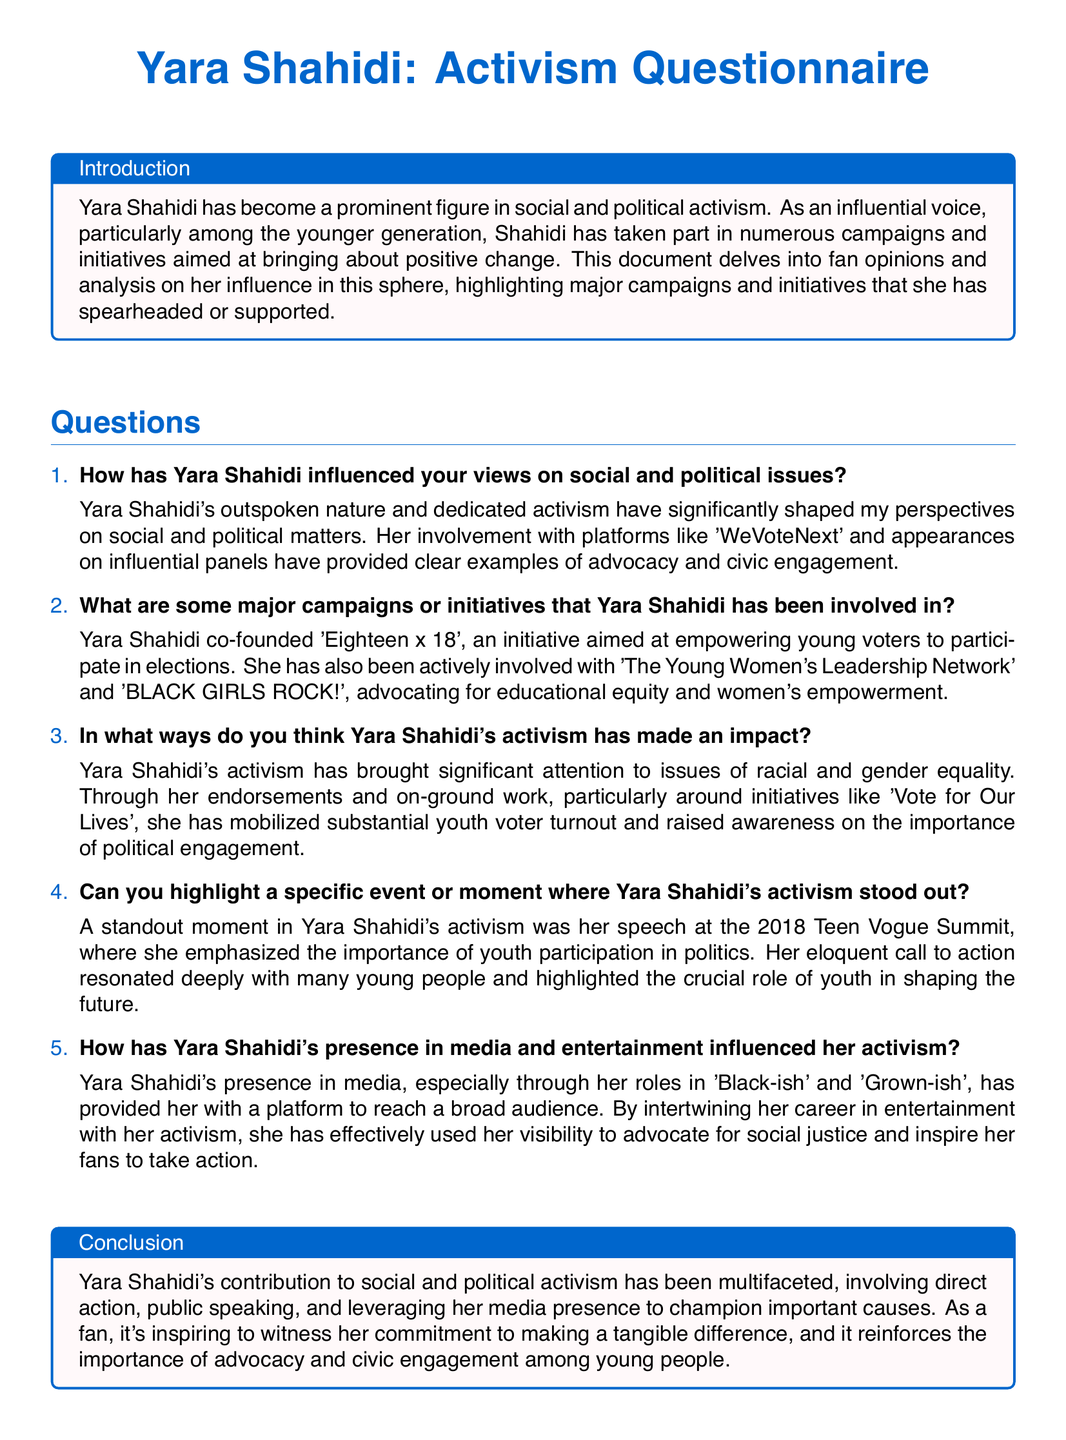What is Yara Shahidi's initiative aimed at empowering young voters? The document states that Yara Shahidi co-founded 'Eighteen x 18', which focuses on empowering young voters.
Answer: 'Eighteen x 18' What event highlighted Yara Shahidi's activism in 2018? The document mentions her speech at the 2018 Teen Vogue Summit as a significant moment for her activism.
Answer: 2018 Teen Vogue Summit What organization is Yara Shahidi involved with that advocates for educational equity? According to the document, she is actively involved with 'The Young Women's Leadership Network', which advocates for educational equity.
Answer: 'The Young Women's Leadership Network' How has Yara Shahidi's activism impacted youth voter turnout? The document describes her mobilization of youth voter turnout through initiatives like 'Vote for Our Lives'.
Answer: Mobilized youth voter turnout What role does Yara Shahidi have in media that aids her activism? The document states that she has roles in 'Black-ish' and 'Grown-ish', which help reach a broad audience for her activism.
Answer: 'Black-ish' and 'Grown-ish' What major themes does Yara Shahidi focus on in her activism? The document identifies racial and gender equality as significant themes in her activism.
Answer: Racial and gender equality 